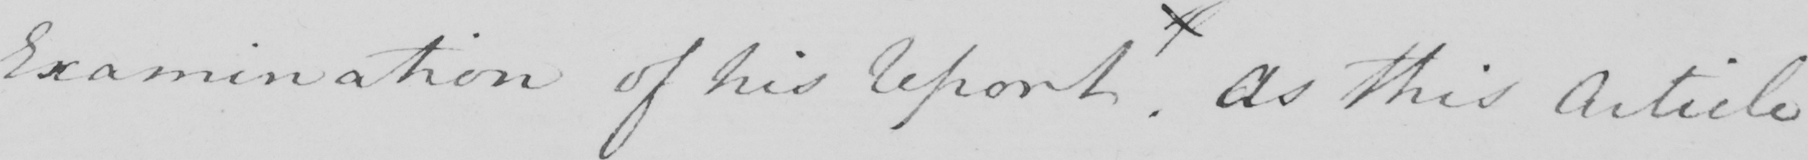Can you read and transcribe this handwriting? Examination of his Report "   . As this Article 